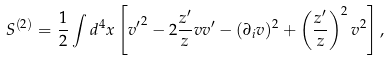<formula> <loc_0><loc_0><loc_500><loc_500>S ^ { ( 2 ) } = \frac { 1 } { 2 } \int d ^ { 4 } x \left [ { v ^ { \prime } } ^ { 2 } - 2 \frac { z ^ { \prime } } { z } v v ^ { \prime } - ( \partial _ { i } v ) ^ { 2 } + \left ( \frac { z ^ { \prime } } { z } \right ) ^ { 2 } v ^ { 2 } \right ] ,</formula> 